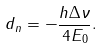<formula> <loc_0><loc_0><loc_500><loc_500>d _ { n } = - \frac { h \Delta \nu } { 4 E _ { 0 } } .</formula> 